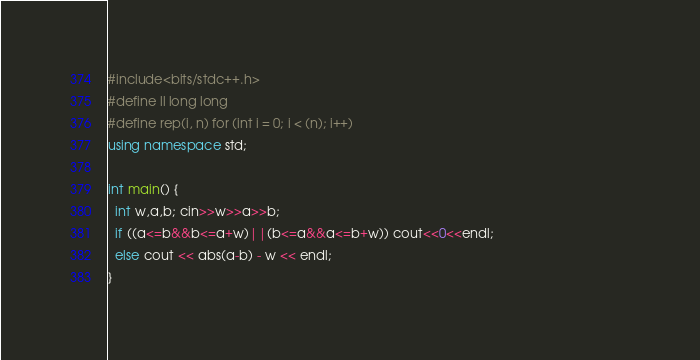<code> <loc_0><loc_0><loc_500><loc_500><_C++_>#include<bits/stdc++.h>                                                                                                       
#define ll long long
#define rep(i, n) for (int i = 0; i < (n); i++)
using namespace std;
 
int main() {
  int w,a,b; cin>>w>>a>>b;
  if ((a<=b&&b<=a+w)||(b<=a&&a<=b+w)) cout<<0<<endl;
  else cout << abs(a-b) - w << endl;
}</code> 